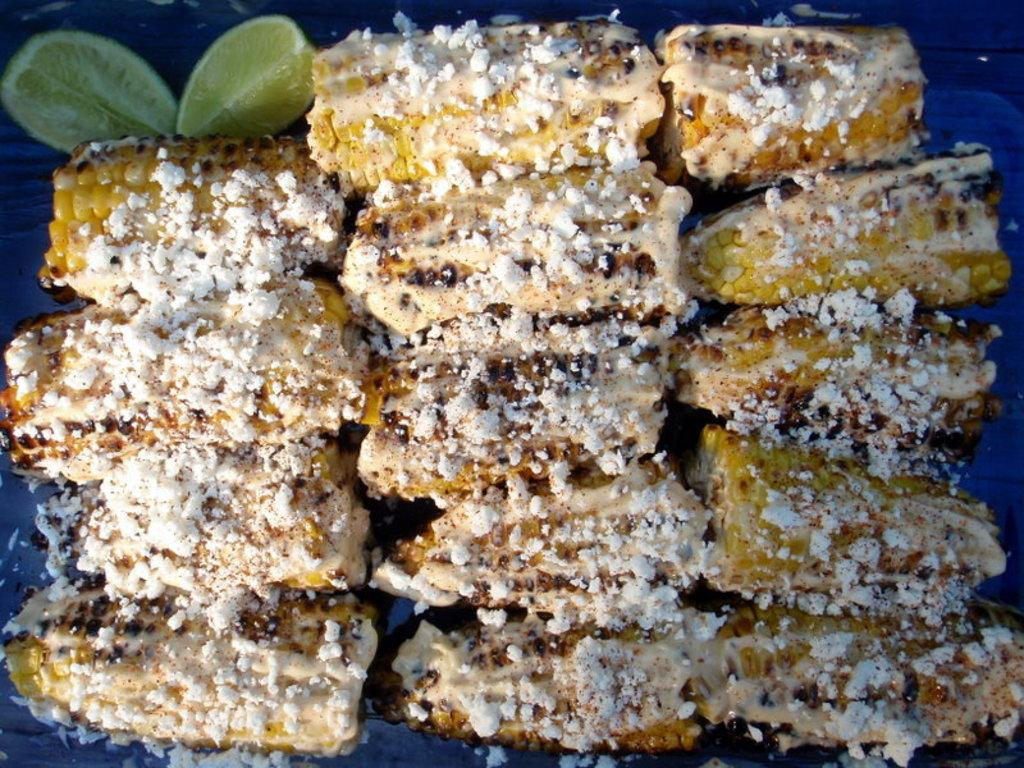What colors can be seen in the food in the image? The food in the image has white, cream, and yellow colors. What type of fruit is featured in the image? There are two lemon slices in the image. What color is the background of the image? The background of the image is blue. Did the earthquake cause any damage to the house in the image? There is no house or earthquake mentioned in the image, so it is not possible to answer that question. 